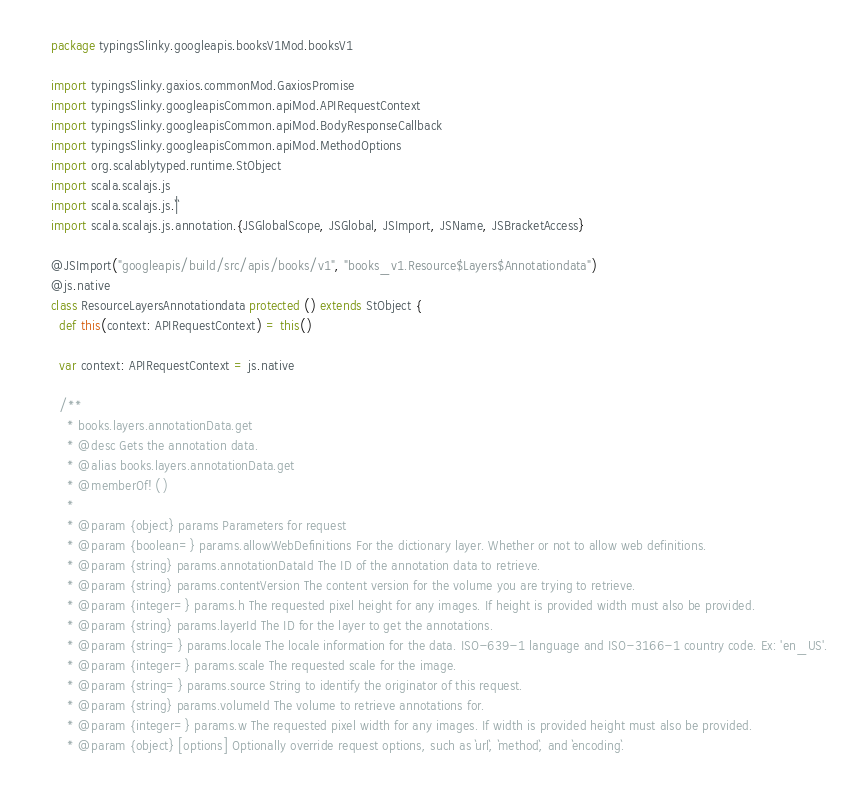Convert code to text. <code><loc_0><loc_0><loc_500><loc_500><_Scala_>package typingsSlinky.googleapis.booksV1Mod.booksV1

import typingsSlinky.gaxios.commonMod.GaxiosPromise
import typingsSlinky.googleapisCommon.apiMod.APIRequestContext
import typingsSlinky.googleapisCommon.apiMod.BodyResponseCallback
import typingsSlinky.googleapisCommon.apiMod.MethodOptions
import org.scalablytyped.runtime.StObject
import scala.scalajs.js
import scala.scalajs.js.`|`
import scala.scalajs.js.annotation.{JSGlobalScope, JSGlobal, JSImport, JSName, JSBracketAccess}

@JSImport("googleapis/build/src/apis/books/v1", "books_v1.Resource$Layers$Annotationdata")
@js.native
class ResourceLayersAnnotationdata protected () extends StObject {
  def this(context: APIRequestContext) = this()
  
  var context: APIRequestContext = js.native
  
  /**
    * books.layers.annotationData.get
    * @desc Gets the annotation data.
    * @alias books.layers.annotationData.get
    * @memberOf! ()
    *
    * @param {object} params Parameters for request
    * @param {boolean=} params.allowWebDefinitions For the dictionary layer. Whether or not to allow web definitions.
    * @param {string} params.annotationDataId The ID of the annotation data to retrieve.
    * @param {string} params.contentVersion The content version for the volume you are trying to retrieve.
    * @param {integer=} params.h The requested pixel height for any images. If height is provided width must also be provided.
    * @param {string} params.layerId The ID for the layer to get the annotations.
    * @param {string=} params.locale The locale information for the data. ISO-639-1 language and ISO-3166-1 country code. Ex: 'en_US'.
    * @param {integer=} params.scale The requested scale for the image.
    * @param {string=} params.source String to identify the originator of this request.
    * @param {string} params.volumeId The volume to retrieve annotations for.
    * @param {integer=} params.w The requested pixel width for any images. If width is provided height must also be provided.
    * @param {object} [options] Optionally override request options, such as `url`, `method`, and `encoding`.</code> 